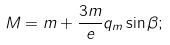Convert formula to latex. <formula><loc_0><loc_0><loc_500><loc_500>M = m + \frac { 3 m } { e } q _ { m } \sin \beta ;</formula> 